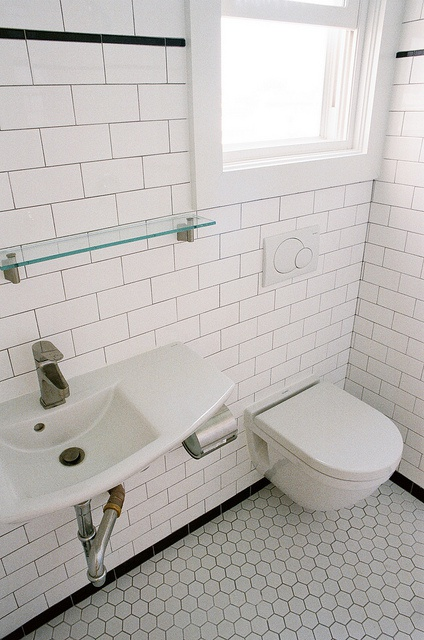Describe the objects in this image and their specific colors. I can see sink in lightgray and darkgray tones and toilet in lightgray, darkgray, and gray tones in this image. 